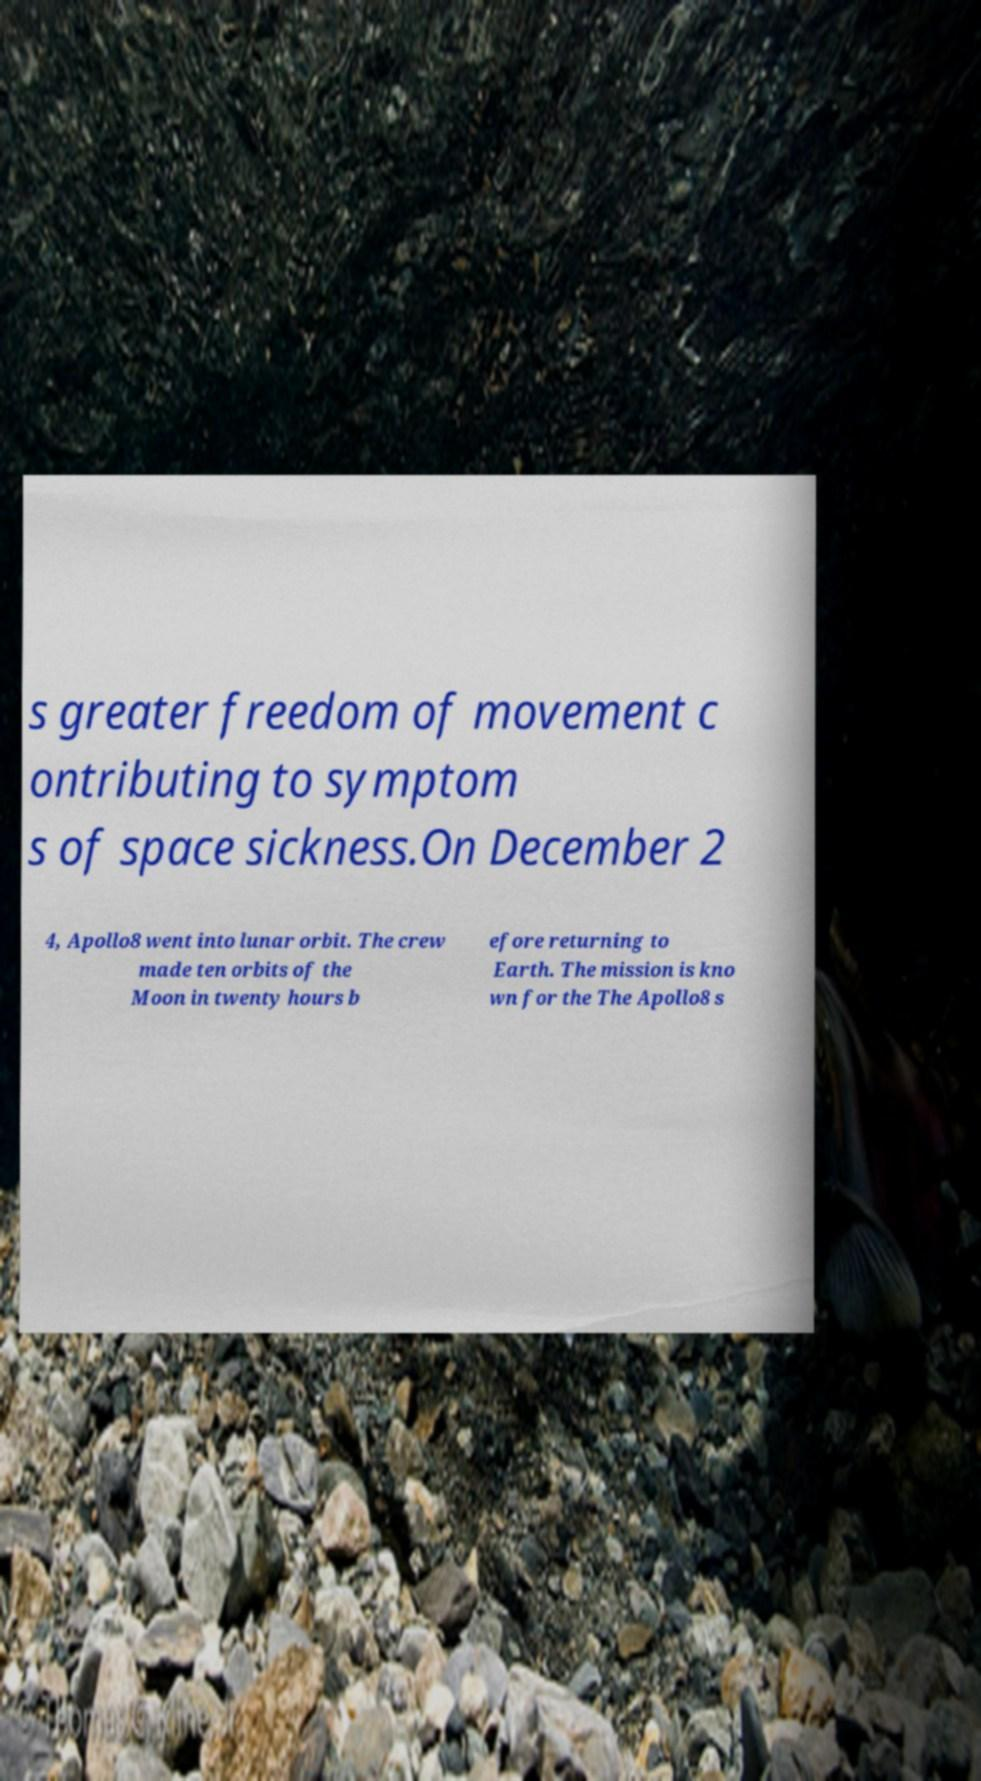Please read and relay the text visible in this image. What does it say? s greater freedom of movement c ontributing to symptom s of space sickness.On December 2 4, Apollo8 went into lunar orbit. The crew made ten orbits of the Moon in twenty hours b efore returning to Earth. The mission is kno wn for the The Apollo8 s 